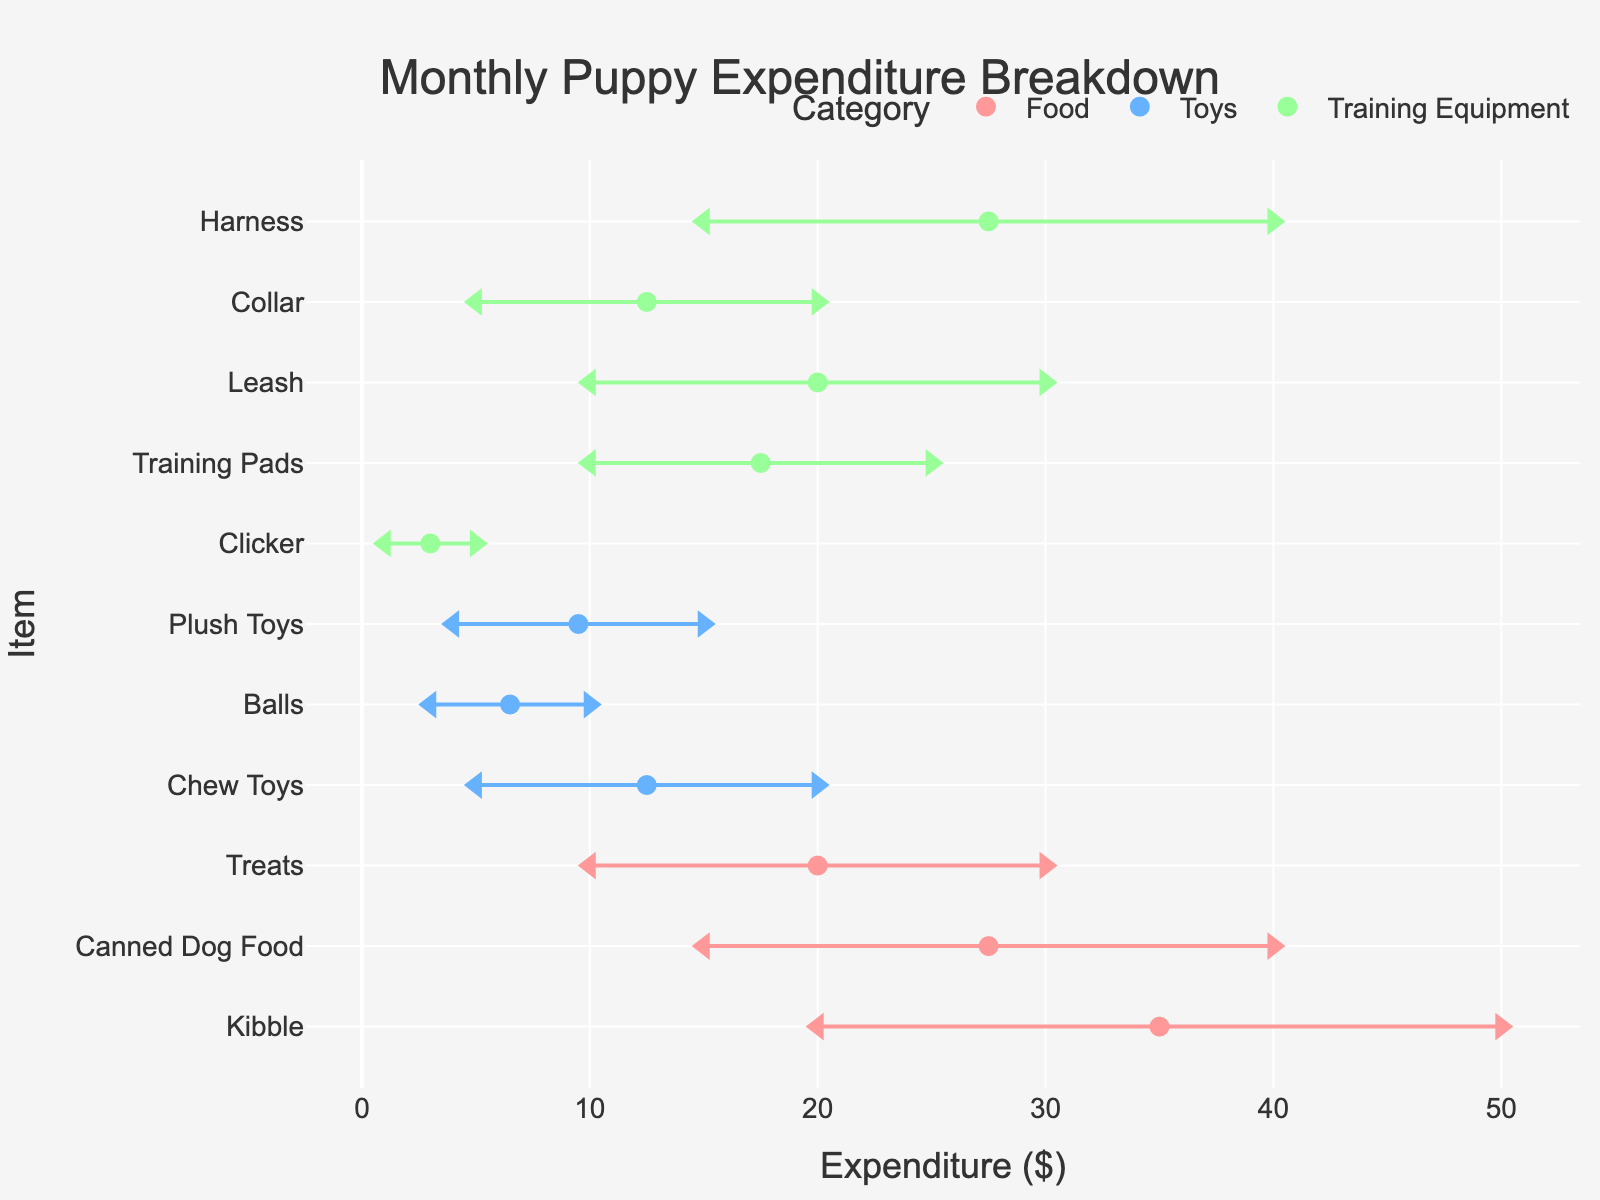What is the title of the plot? The title is typically found at the top center of the plot and summarizes the main content or subject matter of the figure.
Answer: Monthly Puppy Expenditure Breakdown What is the total range of expenditure for Kibble? To find the total range, subtract the minimum value from the maximum value for Kibble. The maximum is $50 and the minimum is $20. So the total range is $50 - $20.
Answer: $30 What is the maximum expenditure for treats? The maximum expenditure for treats can be found by looking for the highest dollar amount listed for treats in the figure legend.
Answer: $30 Which item has the highest average expenditure? To determine this, look at the average values plotted as circles on the chart and find the item with the highest average expenditure. The average for each item can be visually estimated by finding the midpoint between its minimum and maximum markers on the plot.
Answer: Harness Compare the minimum expenditures for Chew Toys and Training Pads. Which is higher? Locate the minimum expenditure markers for both Chew Toys and Training Pads by looking at the leftmost points for these items. Compare their values directly.
Answer: Training Pads What is the average expenditure range for food items? Calculate the average expenditure for each food item by averaging the minimum and maximum, then compute the average across all food items. For Kibble: (20+50)/2 = 35, for Canned Dog Food: (15+40)/2 = 27.5, and for Treats: (10+30)/2 = 20. Finally, average these values: (35 + 27.5 + 20) / 3.
Answer: $27.5 Which category has the most items listed? Identify the categories (Food, Toys, Training Equipment) and count the number of items in each category.
Answer: Training Equipment Among the listed items, what is the range of expenditure for the Clicker? Find the minimum and maximum values for the Clicker listed under Training Equipment. Range is calculated as $5 - $1.
Answer: $4 Between Leash and Collar, which has a higher maximum expenditure? Compare the maximum expenditure values for Leash and Collar from their respective markers on the plot.
Answer: Leash 